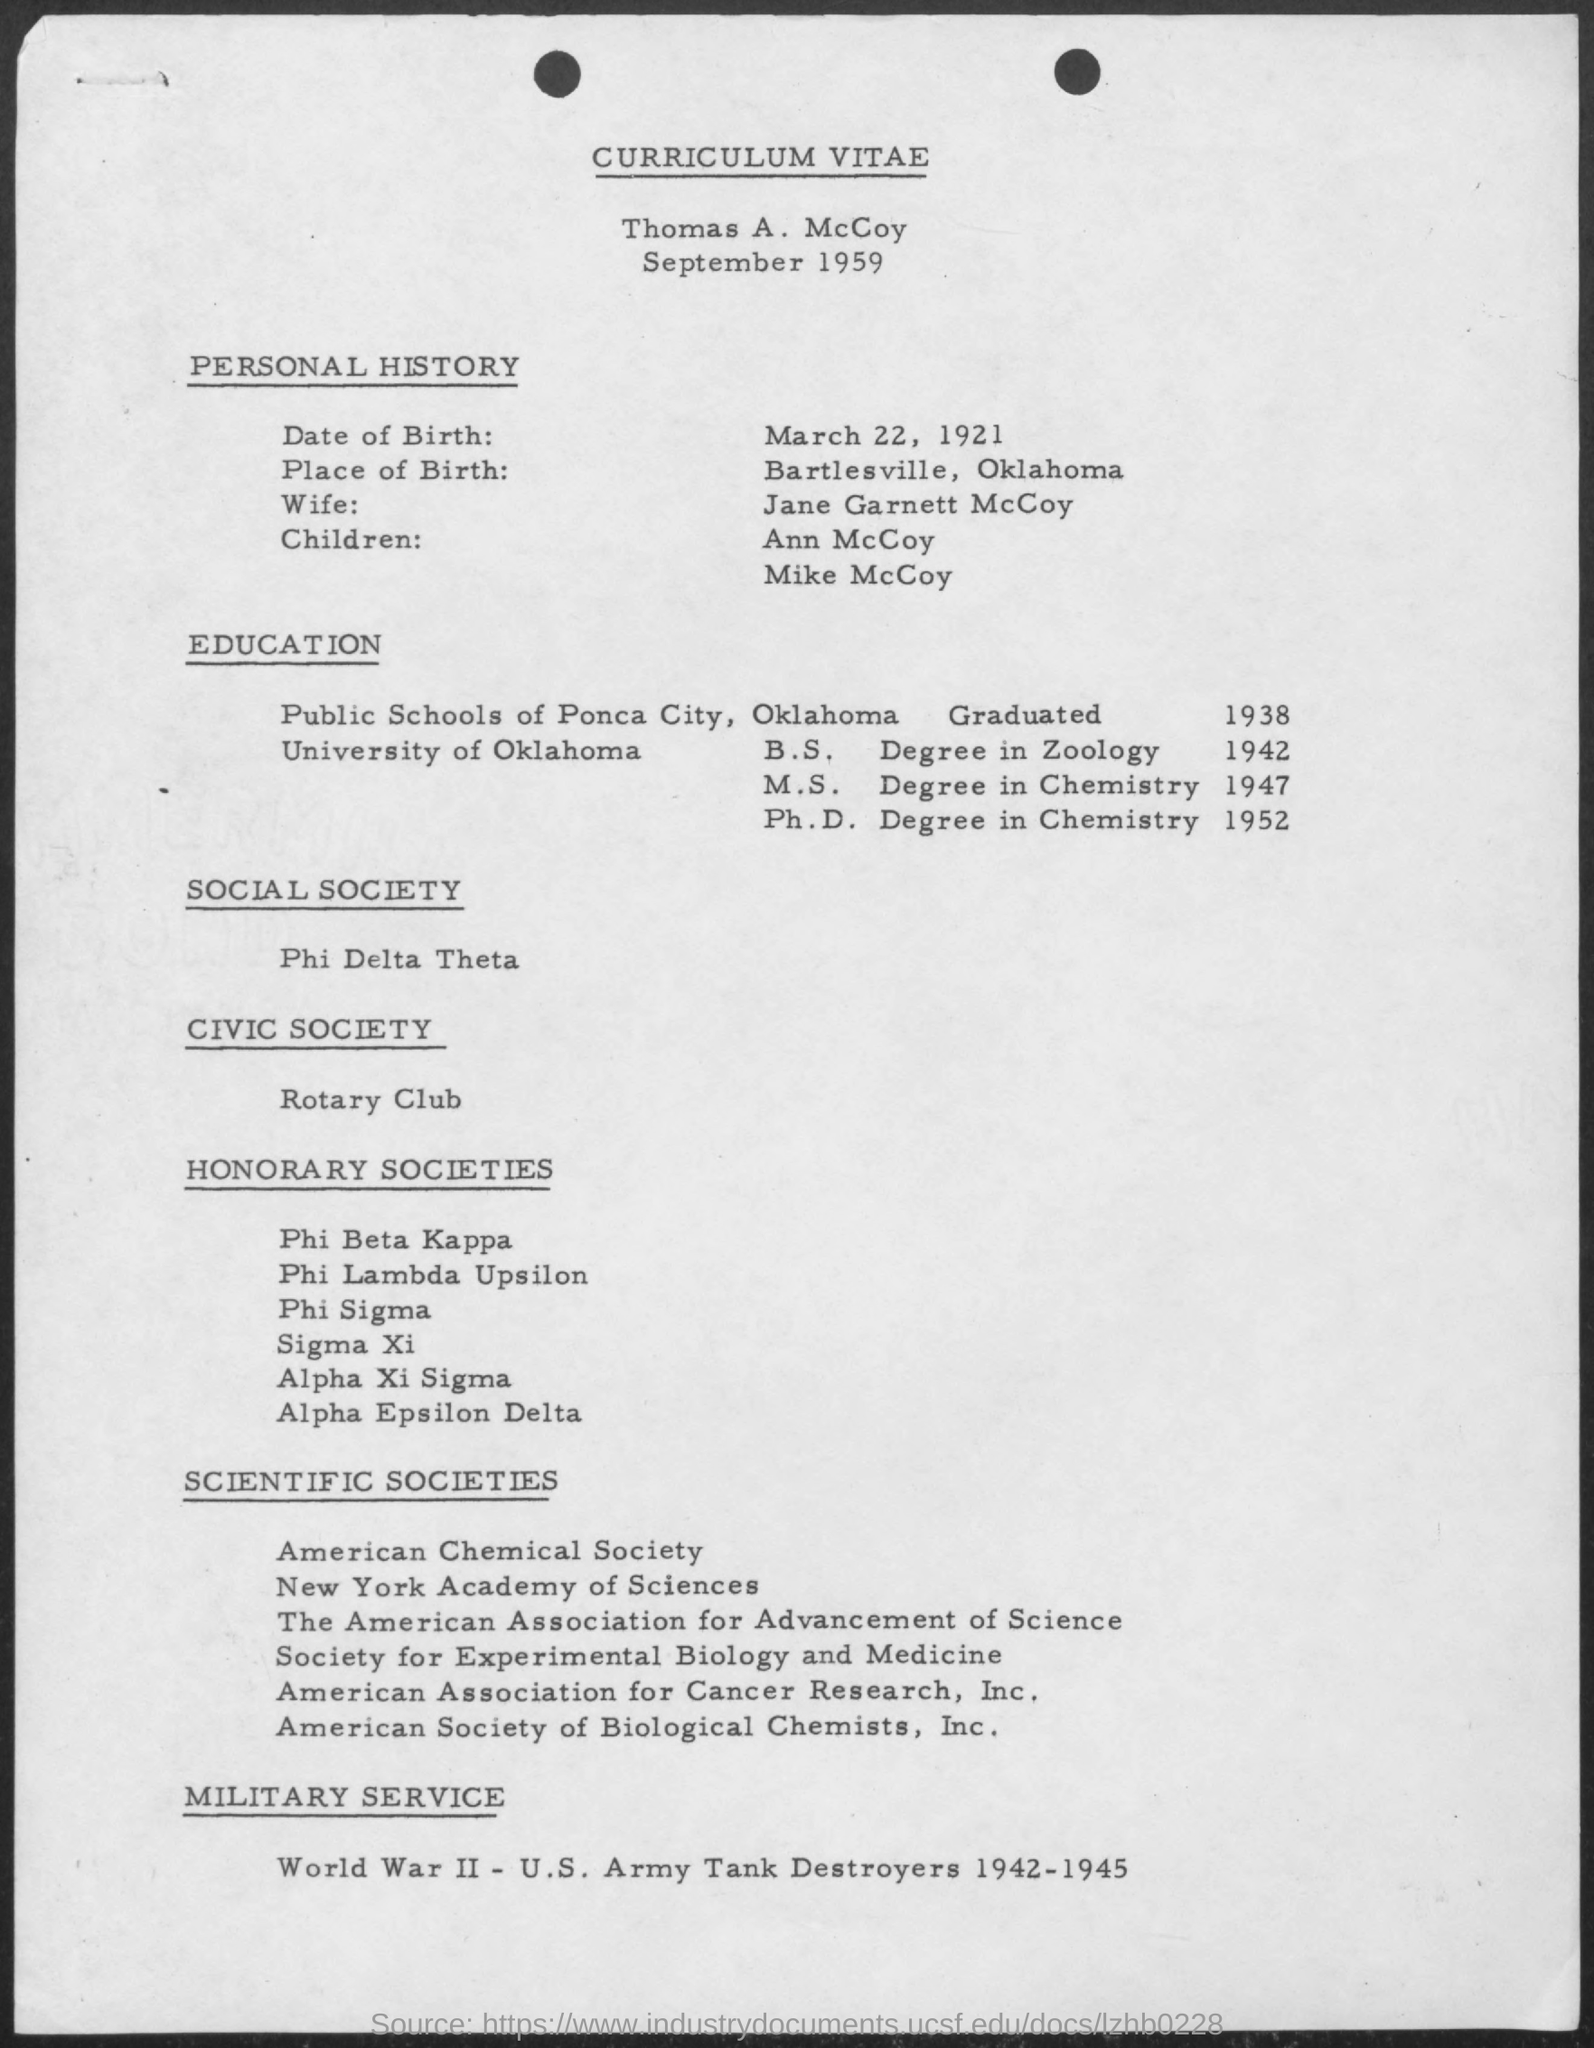Whose curriculum vitae is provided here?
Make the answer very short. Thomas A. McCoy. What is the date of birth of Thomas A. McCoy?
Keep it short and to the point. March 22, 1921. What is the place of birth of Thomas A. McCoy?
Provide a short and direct response. Bartlesville, Oklahoma. Who is the wife of Thomas A. McCoy?
Offer a very short reply. Jane Garnett McCoy. In which university, Thomas A. McCoy did M.S degree in Chemistry?
Offer a terse response. University of Oklahoma. When did Thomas A. McCoy completed his M. S. degree in chemistry?
Make the answer very short. 1947. When did Thomas A. McCoy completed his Ph. D. degree in chemistry?
Provide a short and direct response. 1952. 